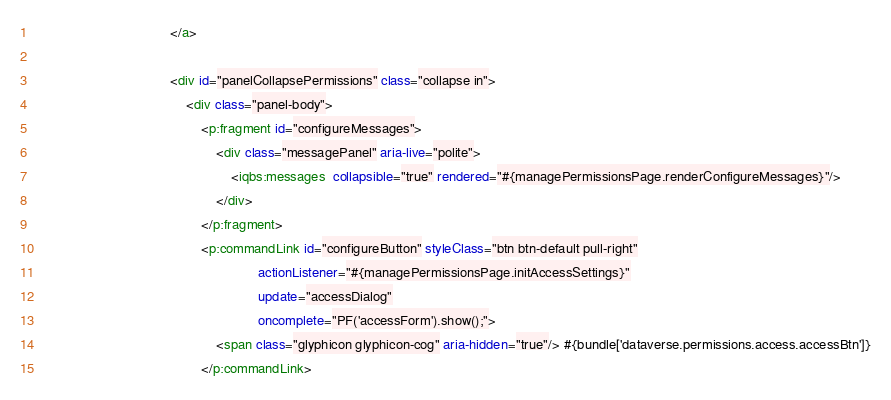<code> <loc_0><loc_0><loc_500><loc_500><_HTML_>                                    </a>
                                    
                                    <div id="panelCollapsePermissions" class="collapse in">
                                        <div class="panel-body">
                                            <p:fragment id="configureMessages">
                                                <div class="messagePanel" aria-live="polite">
                                                    <iqbs:messages  collapsible="true" rendered="#{managePermissionsPage.renderConfigureMessages}"/>
                                                </div>
                                            </p:fragment>
                                            <p:commandLink id="configureButton" styleClass="btn btn-default pull-right"
                                                           actionListener="#{managePermissionsPage.initAccessSettings}"
                                                           update="accessDialog"
                                                           oncomplete="PF('accessForm').show();">
                                                <span class="glyphicon glyphicon-cog" aria-hidden="true"/> #{bundle['dataverse.permissions.access.accessBtn']}
                                            </p:commandLink></code> 